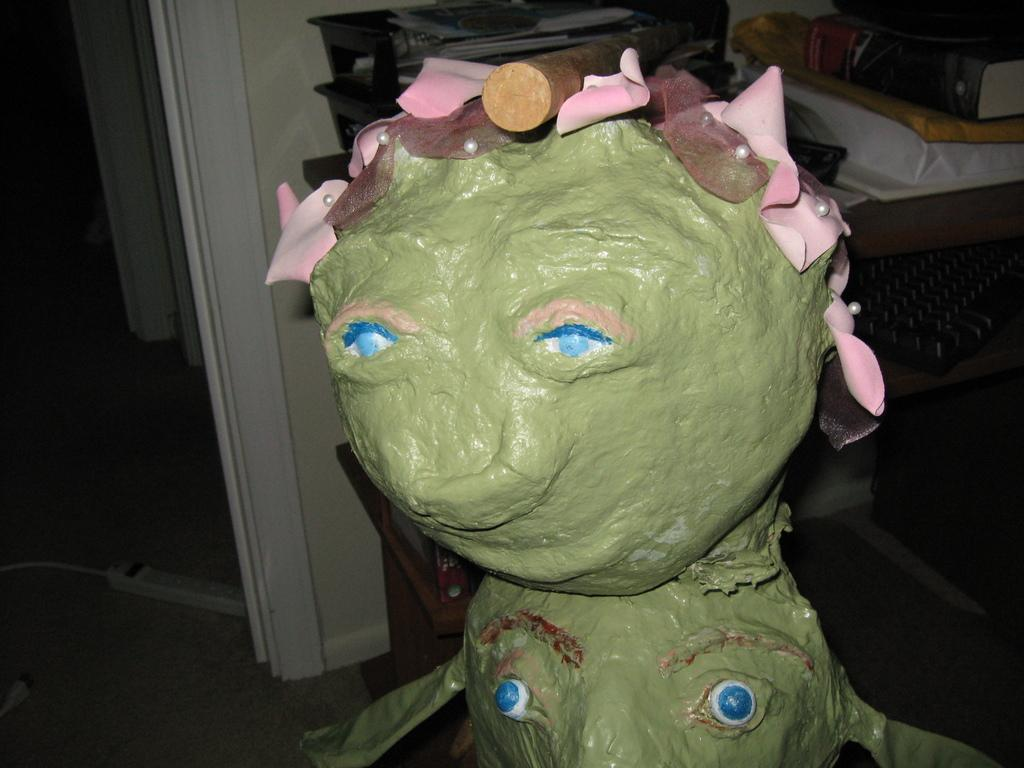What is the main subject in the center of the image? There is a doll in the center of the image. Can you describe the background of the image? There are objects in the background of the image. Is there any blood visible on the doll in the image? No, there is no blood visible on the doll in the image. What is the doll's tendency to move or interact with the objects in the background? The doll's tendency cannot be determined from the image, as it is a static object. 